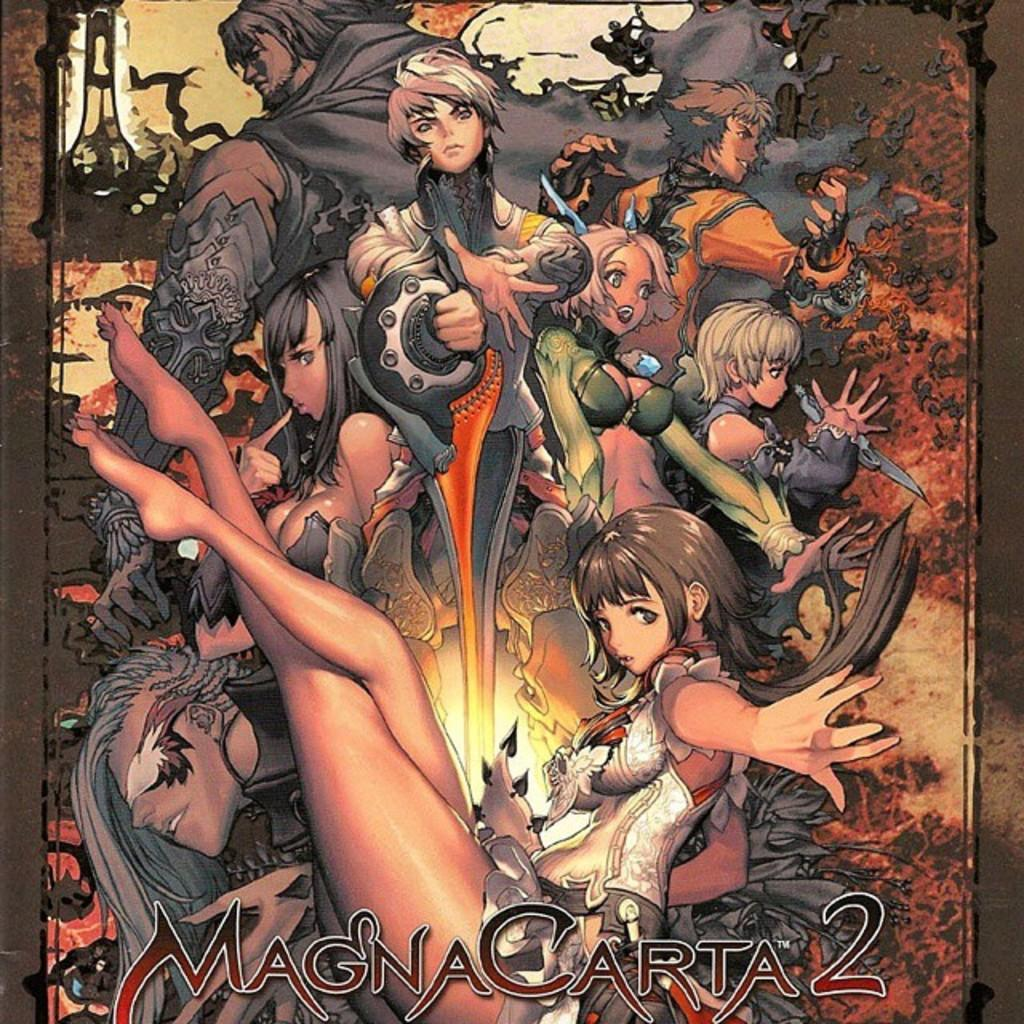What is the main subject of the poster in the image? The poster contains many anime characters. Where are the texts located on the poster? The texts are at the bottom of the poster. How many pets are featured on the poster? There are no pets featured on the poster; it contains anime characters. What type of toothbrush is recommended for cleaning the poster? There is no toothbrush mentioned or implied in the image, as it features a poster with anime characters and text. 